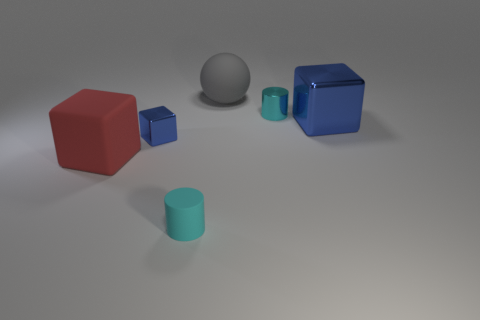Add 4 big yellow shiny cylinders. How many objects exist? 10 Subtract all cylinders. How many objects are left? 4 Add 3 large cyan metallic cubes. How many large cyan metallic cubes exist? 3 Subtract 0 gray blocks. How many objects are left? 6 Subtract all tiny metal cylinders. Subtract all big blue things. How many objects are left? 4 Add 4 large red things. How many large red things are left? 5 